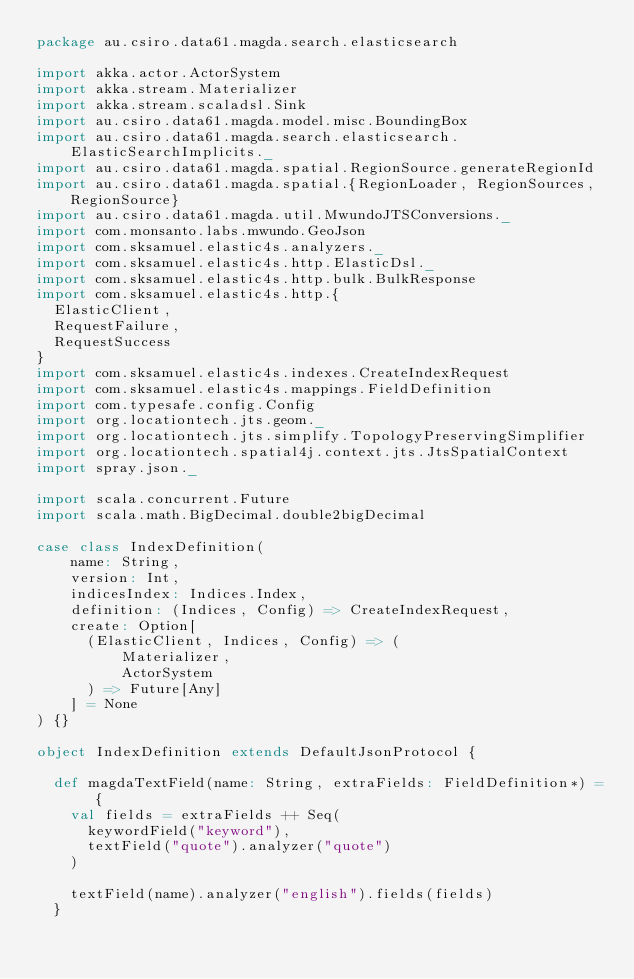Convert code to text. <code><loc_0><loc_0><loc_500><loc_500><_Scala_>package au.csiro.data61.magda.search.elasticsearch

import akka.actor.ActorSystem
import akka.stream.Materializer
import akka.stream.scaladsl.Sink
import au.csiro.data61.magda.model.misc.BoundingBox
import au.csiro.data61.magda.search.elasticsearch.ElasticSearchImplicits._
import au.csiro.data61.magda.spatial.RegionSource.generateRegionId
import au.csiro.data61.magda.spatial.{RegionLoader, RegionSources, RegionSource}
import au.csiro.data61.magda.util.MwundoJTSConversions._
import com.monsanto.labs.mwundo.GeoJson
import com.sksamuel.elastic4s.analyzers._
import com.sksamuel.elastic4s.http.ElasticDsl._
import com.sksamuel.elastic4s.http.bulk.BulkResponse
import com.sksamuel.elastic4s.http.{
  ElasticClient,
  RequestFailure,
  RequestSuccess
}
import com.sksamuel.elastic4s.indexes.CreateIndexRequest
import com.sksamuel.elastic4s.mappings.FieldDefinition
import com.typesafe.config.Config
import org.locationtech.jts.geom._
import org.locationtech.jts.simplify.TopologyPreservingSimplifier
import org.locationtech.spatial4j.context.jts.JtsSpatialContext
import spray.json._

import scala.concurrent.Future
import scala.math.BigDecimal.double2bigDecimal

case class IndexDefinition(
    name: String,
    version: Int,
    indicesIndex: Indices.Index,
    definition: (Indices, Config) => CreateIndexRequest,
    create: Option[
      (ElasticClient, Indices, Config) => (
          Materializer,
          ActorSystem
      ) => Future[Any]
    ] = None
) {}

object IndexDefinition extends DefaultJsonProtocol {

  def magdaTextField(name: String, extraFields: FieldDefinition*) = {
    val fields = extraFields ++ Seq(
      keywordField("keyword"),
      textField("quote").analyzer("quote")
    )

    textField(name).analyzer("english").fields(fields)
  }
</code> 